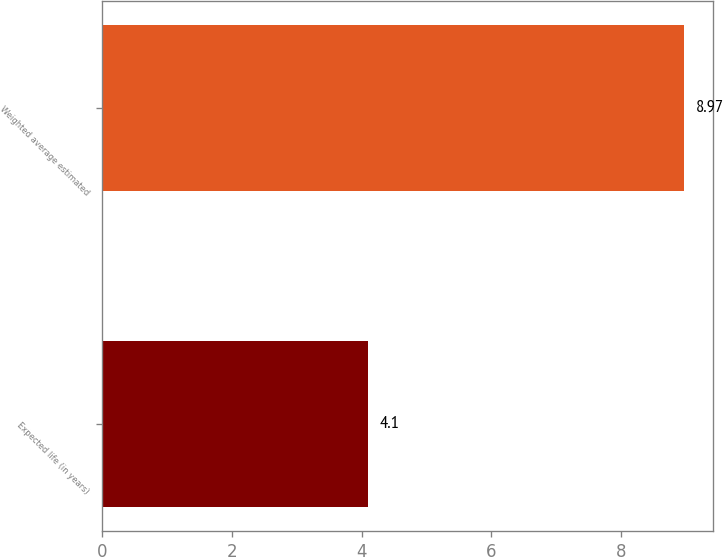Convert chart. <chart><loc_0><loc_0><loc_500><loc_500><bar_chart><fcel>Expected life (in years)<fcel>Weighted average estimated<nl><fcel>4.1<fcel>8.97<nl></chart> 